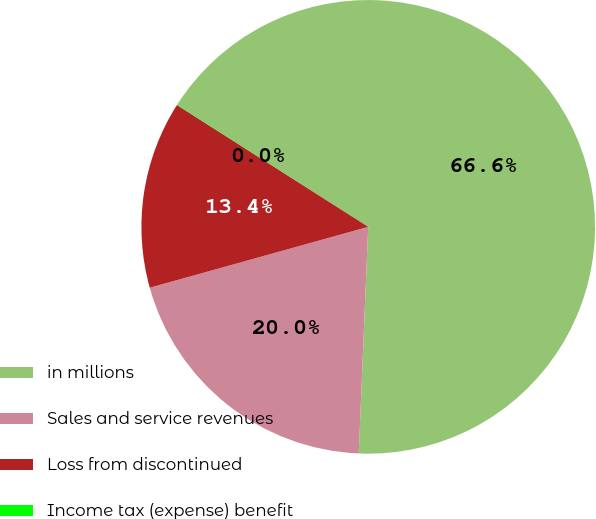Convert chart to OTSL. <chart><loc_0><loc_0><loc_500><loc_500><pie_chart><fcel>in millions<fcel>Sales and service revenues<fcel>Loss from discontinued<fcel>Income tax (expense) benefit<nl><fcel>66.61%<fcel>20.01%<fcel>13.35%<fcel>0.03%<nl></chart> 